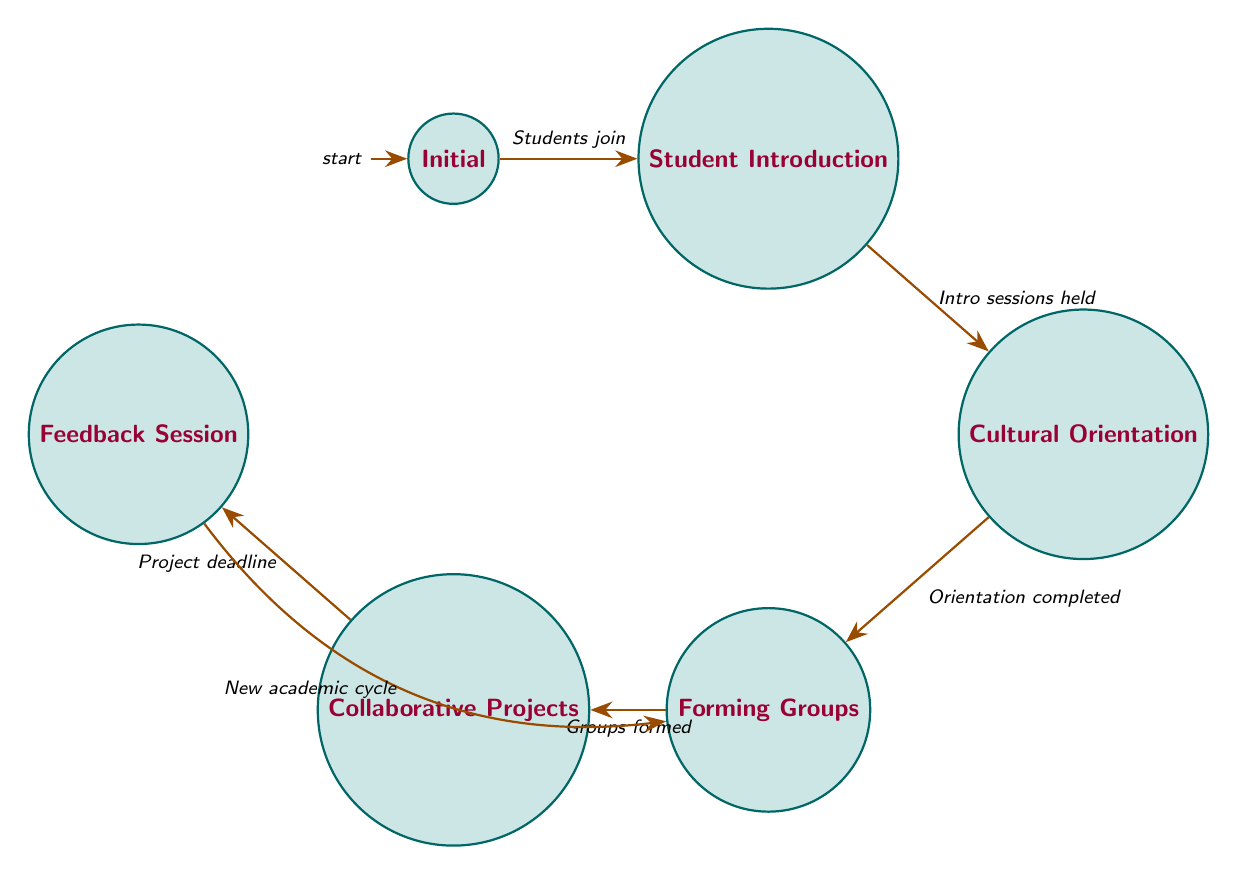What's the total number of states in the diagram? The diagram lists six distinct states: Initial, Student Introduction, Cultural Orientation, Forming Groups, Collaborative Projects, and Feedback Session. Counting these gives a total of six states.
Answer: 6 What is the first state in the transition process? The starting state, highlighted as 'Initial,' is where the process begins when students join the university. This is the first point in the transition flow according to the diagram.
Answer: Initial What action is taken when students form groups? According to the diagram, when groups are formed, the action that follows is that students start working on cross-cultural projects. This indicates the purpose of establishing those groups.
Answer: Students start working on cross-cultural projects Which transition occurs after students receive and provide feedback? As illustrated in the diagram, after the feedback session, the next transition occurs back to 'Forming Groups' when a new academic cycle begins. This indicates the cyclical nature of the process.
Answer: Forming Groups How many transitions lead to the 'Collaborative Projects' state? The diagram specifies that there is one transition that leads to the 'Collaborative Projects' state, specifically from 'Forming Groups' after the groups are formed. This indicates a direct path to this state.
Answer: 1 What triggers the transition from 'Cultural Orientation' to 'Forming Groups'? The trigger for moving from 'Cultural Orientation' to 'Forming Groups' is the completion of orientation sessions. This is the condition that must be fulfilled before transitioning to the next state.
Answer: Orientation sessions completed What action do students take after the project deadline is reached? After the project deadline is reached, the action taken by students is to provide and receive peer feedback, highlighting the reflective nature of their collaborative efforts.
Answer: Students provide and receive peer feedback Which state do students return to at the beginning of a new academic cycle? When a new academic cycle begins, students return to 'Forming Groups', indicating a reset for new collaborative opportunities in their education journey.
Answer: Forming Groups 